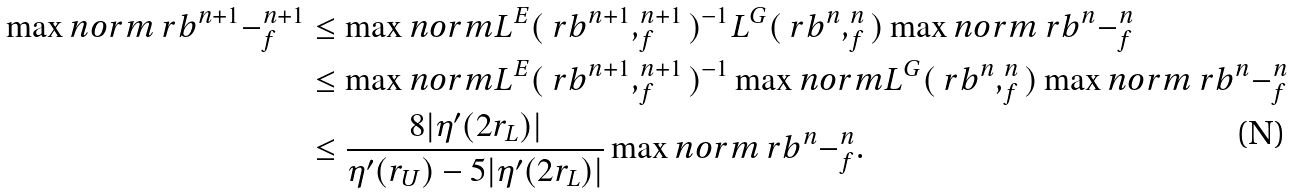Convert formula to latex. <formula><loc_0><loc_0><loc_500><loc_500>\max n o r m { \ r b ^ { n + 1 } - _ { f } ^ { n + 1 } } & \leq \max n o r m { L ^ { E } ( \ r b ^ { n + 1 } , _ { f } ^ { n + 1 } ) ^ { - 1 } L ^ { G } ( \ r b ^ { n } , _ { f } ^ { n } ) } \max n o r m { \ r b ^ { n } - _ { f } ^ { n } } \\ & \leq \max n o r m { L ^ { E } ( \ r b ^ { n + 1 } , _ { f } ^ { n + 1 } ) ^ { - 1 } } \max n o r m { L ^ { G } ( \ r b ^ { n } , _ { f } ^ { n } ) } \max n o r m { \ r b ^ { n } - _ { f } ^ { n } } \\ & \leq \frac { 8 | \eta ^ { \prime } ( 2 r _ { L } ) | } { \eta ^ { \prime } ( r _ { U } ) - 5 | \eta ^ { \prime } ( 2 r _ { L } ) | } \max n o r m { \ r b ^ { n } - _ { f } ^ { n } } .</formula> 